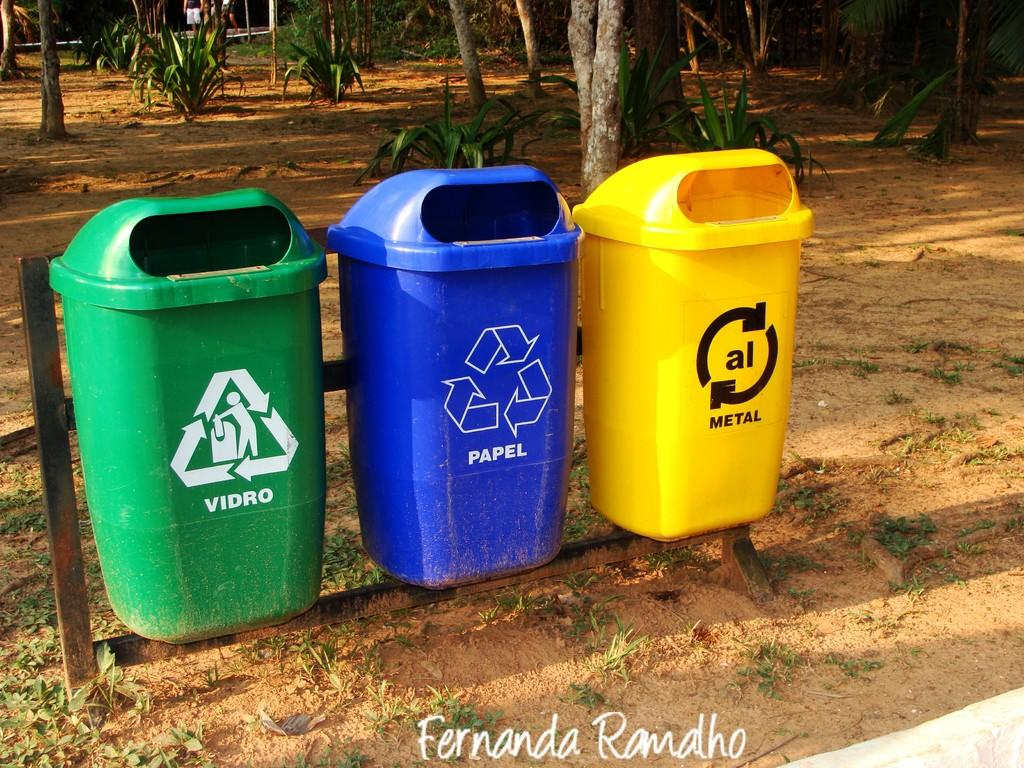<image>
Offer a succinct explanation of the picture presented. A blue recycling can says Papel on it with a recycling symbol. 